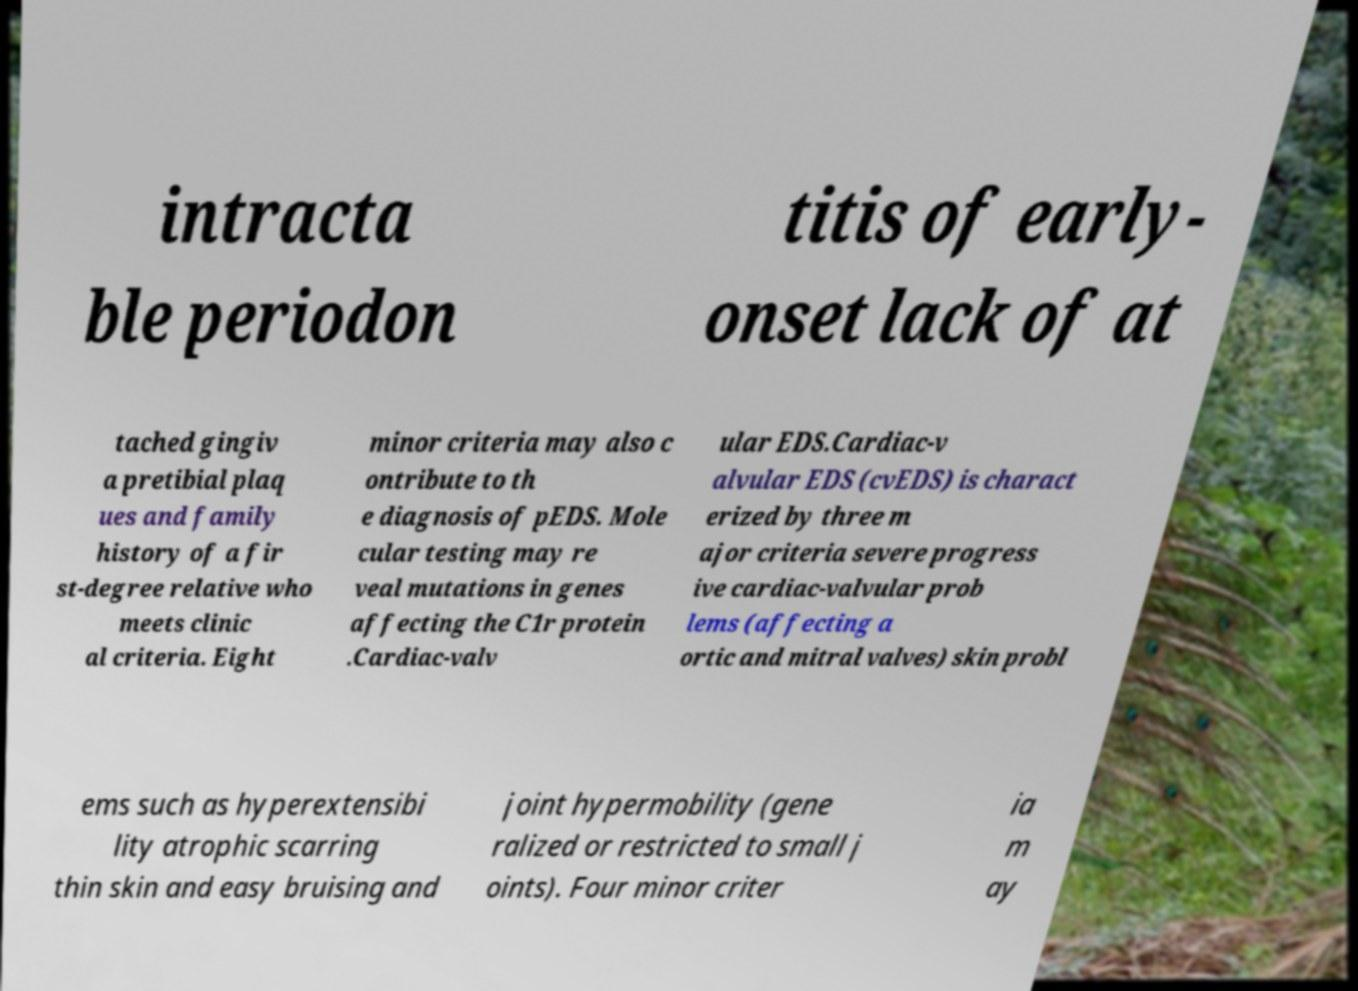Can you accurately transcribe the text from the provided image for me? intracta ble periodon titis of early- onset lack of at tached gingiv a pretibial plaq ues and family history of a fir st-degree relative who meets clinic al criteria. Eight minor criteria may also c ontribute to th e diagnosis of pEDS. Mole cular testing may re veal mutations in genes affecting the C1r protein .Cardiac-valv ular EDS.Cardiac-v alvular EDS (cvEDS) is charact erized by three m ajor criteria severe progress ive cardiac-valvular prob lems (affecting a ortic and mitral valves) skin probl ems such as hyperextensibi lity atrophic scarring thin skin and easy bruising and joint hypermobility (gene ralized or restricted to small j oints). Four minor criter ia m ay 